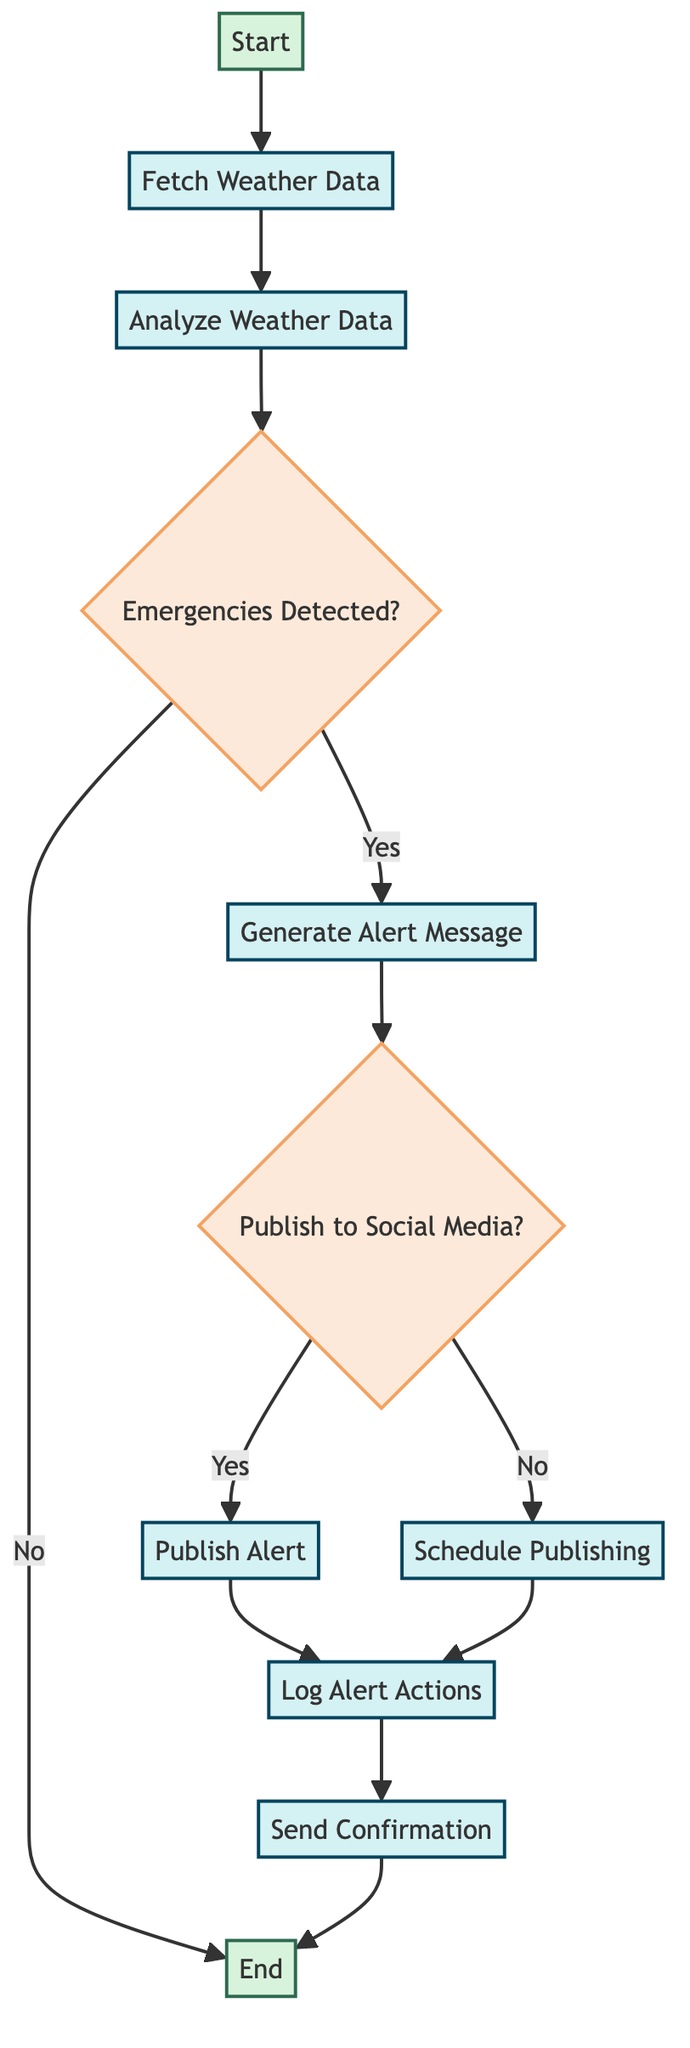What is the first step in the flowchart? The first step in the flowchart is labeled "Start," indicating the beginning of the weather alert notification function.
Answer: Start How many decision nodes are present in the flowchart? The flowchart contains two decision nodes: "Emergencies Detected?" and "Publish to Social Media?"
Answer: 2 What happens if no emergencies are detected? If no emergencies are detected, the process ends at the "End" node, without generating any alert message.
Answer: End What are the two options after generating an alert message? After generating an alert message, the two options are to "Publish Alert" or "Schedule Publishing."
Answer: Publish Alert, Schedule Publishing What action is taken after a decision to publish the alert? After the decision to publish the alert, the next action taken is to "Log Alert Actions." This keeps track of the alert publishing for accountability.
Answer: Log Alert Actions What is logged after alert actions? After alert actions, the "Log Alert Actions" process logs all alert publishing actions for accountability and future auditing.
Answer: Log Alert Actions What is the final action taken in the flowchart? The final action taken in the flowchart is sending a confirmation notification to the relevant government officials after publishing or scheduling the alert.
Answer: Send Confirmation How does the flowchart determine if emergency conditions are present? The flowchart checks for emergency conditions through the decision node labeled "Emergencies Detected?", which evaluates the analyzed weather data against predefined thresholds.
Answer: Emergencies Detected? What does the flowchart suggest happens if the alert is not published immediately? If the alert is not published immediately, the flowchart indicates that it will be scheduled for publishing at a specific time.
Answer: Schedule Publishing 